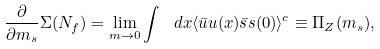Convert formula to latex. <formula><loc_0><loc_0><loc_500><loc_500>\frac { \partial } { \partial m _ { s } } \Sigma ( N _ { f } ) = \lim _ { m \to 0 } \int \ d x \langle \bar { u } u ( x ) \bar { s } s ( 0 ) \rangle ^ { c } \equiv \Pi _ { Z } ( m _ { s } ) ,</formula> 